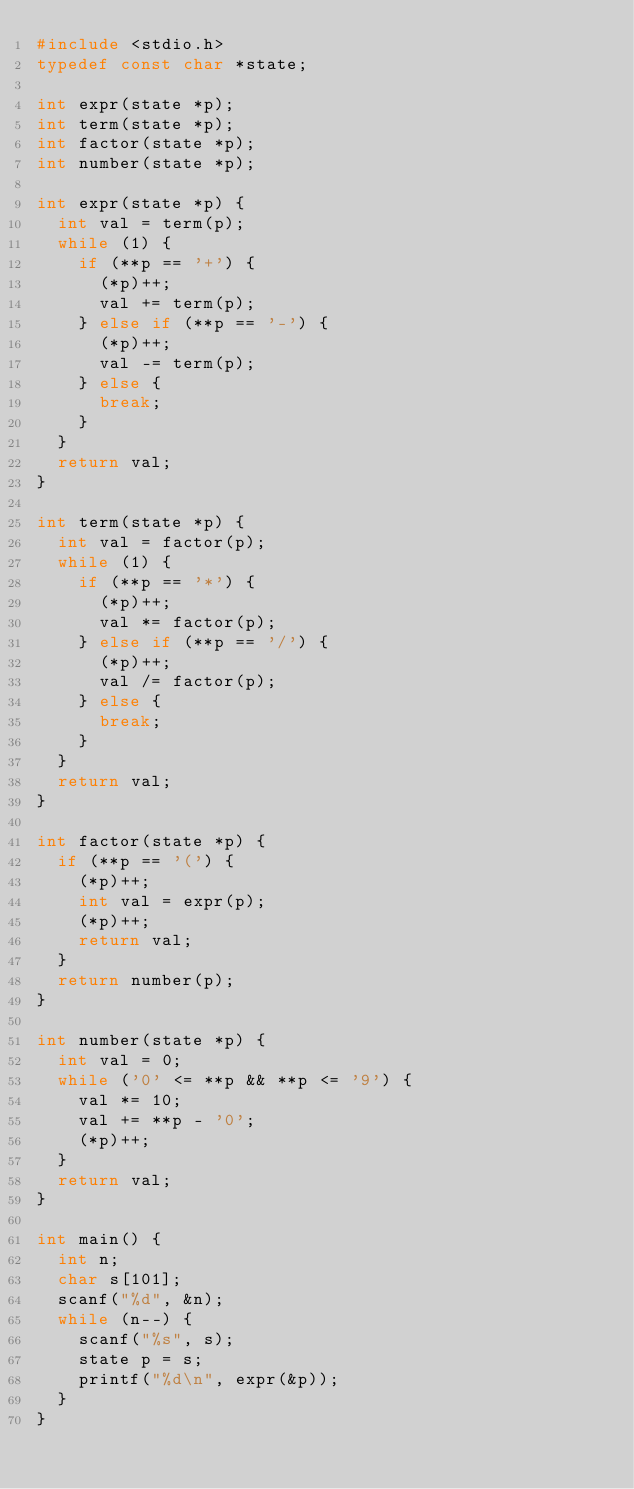<code> <loc_0><loc_0><loc_500><loc_500><_C_>#include <stdio.h>
typedef const char *state;

int expr(state *p);
int term(state *p);
int factor(state *p);
int number(state *p);

int expr(state *p) {
  int val = term(p);
  while (1) {
    if (**p == '+') {
      (*p)++;
      val += term(p);
    } else if (**p == '-') {
      (*p)++;
      val -= term(p);
    } else {
      break;
    }
  }
  return val;
}

int term(state *p) {
  int val = factor(p);
  while (1) {
    if (**p == '*') {
      (*p)++;
      val *= factor(p);
    } else if (**p == '/') {
      (*p)++;
      val /= factor(p);
    } else {
      break;
    }
  }
  return val;
}

int factor(state *p) {
  if (**p == '(') {
    (*p)++;
    int val = expr(p);
    (*p)++;
    return val;
  }
  return number(p);
}

int number(state *p) {
  int val = 0;
  while ('0' <= **p && **p <= '9') {
    val *= 10;
    val += **p - '0';
    (*p)++;
  }
  return val;
}

int main() {
  int n;
  char s[101];
  scanf("%d", &n);
  while (n--) {
    scanf("%s", s);
    state p = s;
    printf("%d\n", expr(&p));
  }
}</code> 